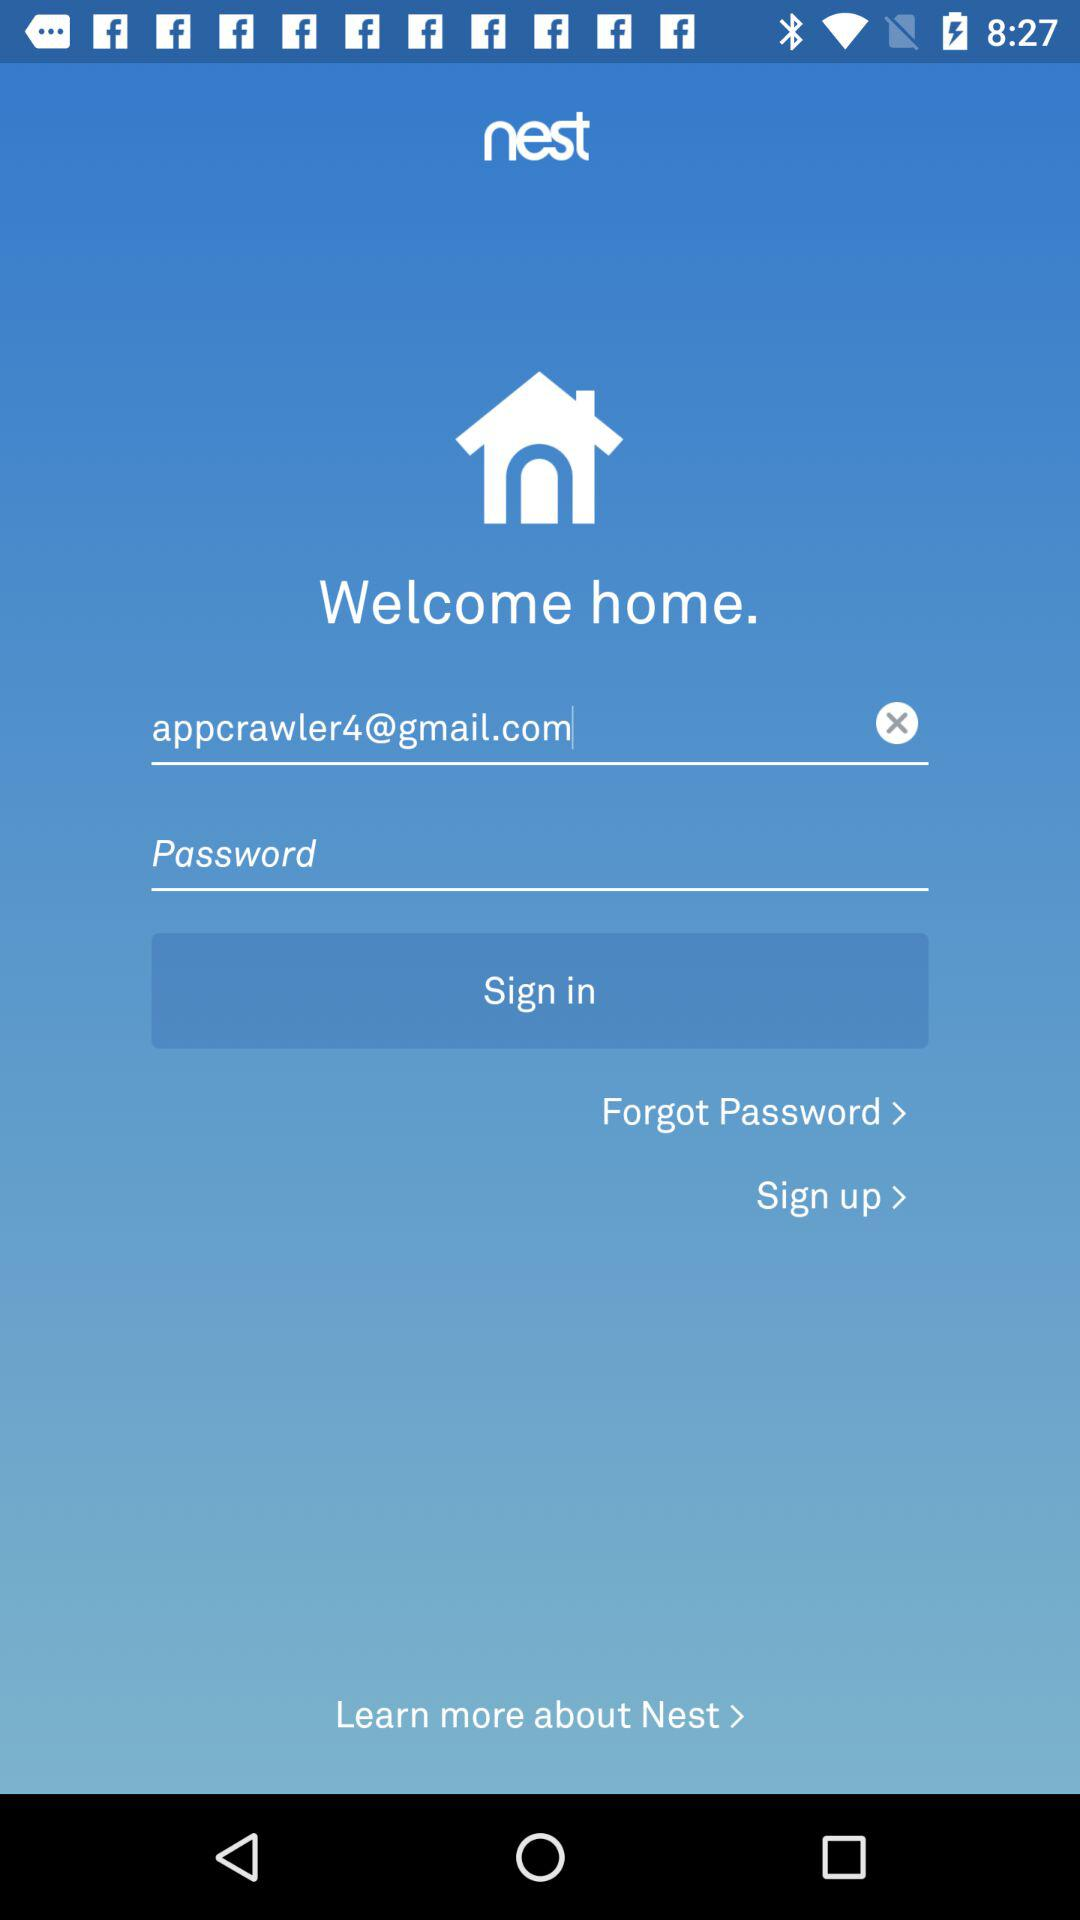What is the email address? The email address is appcrawler4@gmail.com. 